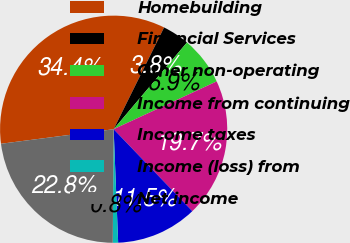<chart> <loc_0><loc_0><loc_500><loc_500><pie_chart><fcel>Homebuilding<fcel>Financial Services<fcel>Other non-operating<fcel>Income from continuing<fcel>Income taxes<fcel>Income (loss) from<fcel>Net income<nl><fcel>34.37%<fcel>3.84%<fcel>6.92%<fcel>19.74%<fcel>11.54%<fcel>0.76%<fcel>22.83%<nl></chart> 